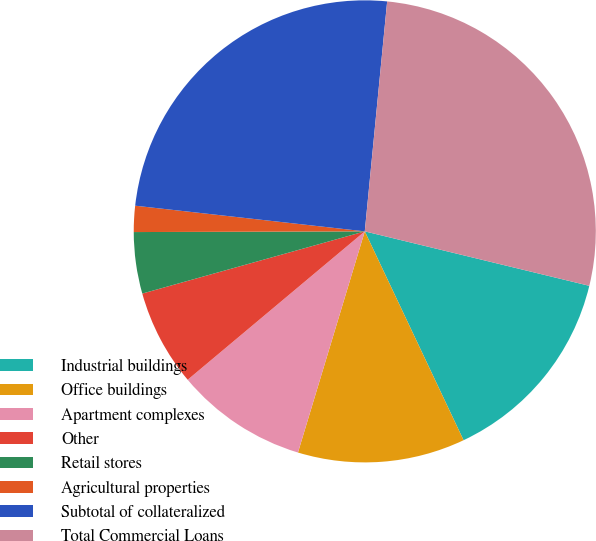Convert chart. <chart><loc_0><loc_0><loc_500><loc_500><pie_chart><fcel>Industrial buildings<fcel>Office buildings<fcel>Apartment complexes<fcel>Other<fcel>Retail stores<fcel>Agricultural properties<fcel>Subtotal of collateralized<fcel>Total Commercial Loans<nl><fcel>14.18%<fcel>11.7%<fcel>9.23%<fcel>6.76%<fcel>4.29%<fcel>1.82%<fcel>24.77%<fcel>27.24%<nl></chart> 